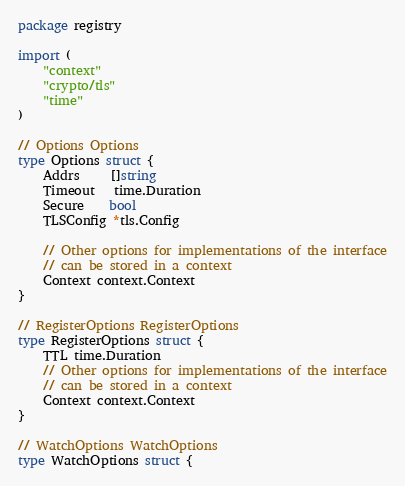<code> <loc_0><loc_0><loc_500><loc_500><_Go_>package registry

import (
	"context"
	"crypto/tls"
	"time"
)

// Options Options
type Options struct {
	Addrs     []string
	Timeout   time.Duration
	Secure    bool
	TLSConfig *tls.Config

	// Other options for implementations of the interface
	// can be stored in a context
	Context context.Context
}

// RegisterOptions RegisterOptions
type RegisterOptions struct {
	TTL time.Duration
	// Other options for implementations of the interface
	// can be stored in a context
	Context context.Context
}

// WatchOptions WatchOptions
type WatchOptions struct {</code> 